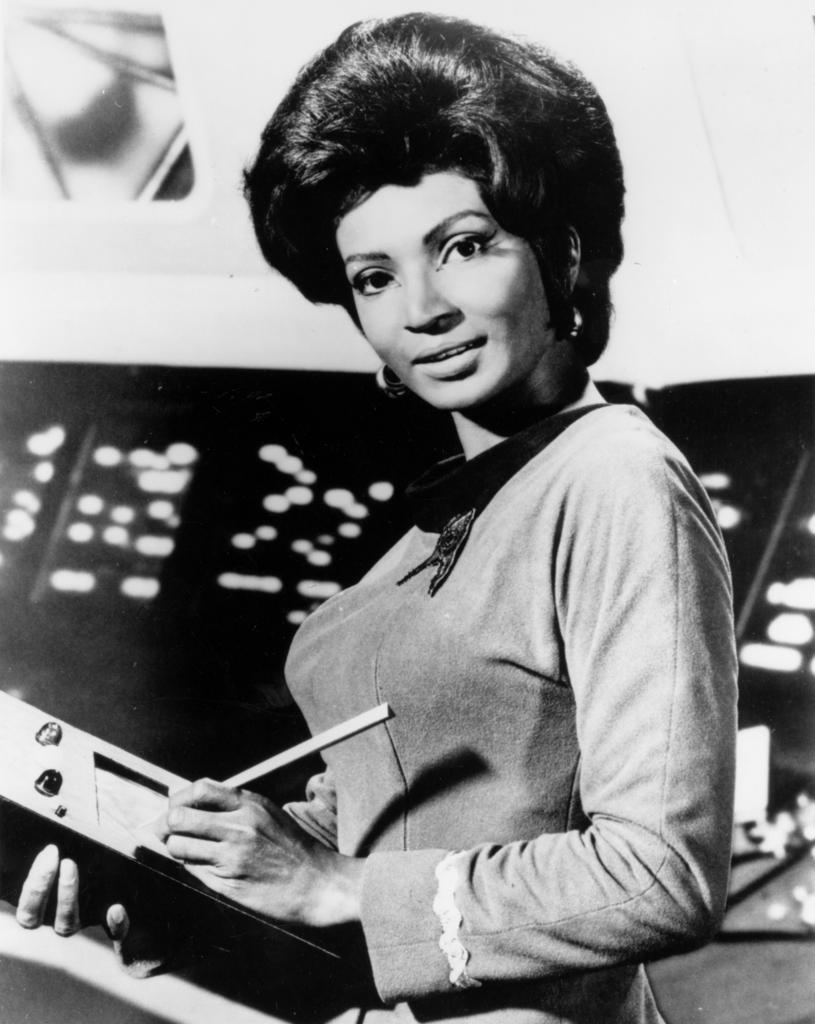Who is the main subject in the image? There is a lady in the image. What is the lady holding in the image? The lady is holding a book. What is the lady doing with the book? The lady is writing on the book. How is the image presented? The image is in black and white mode. What else can be seen in the background of the image? There are other objects visible in the background. What type of teeth can be seen in the lady's mouth in the image? There is no indication of the lady's teeth in the image, as it is in black and white mode and focuses on the lady holding and writing on a book. 